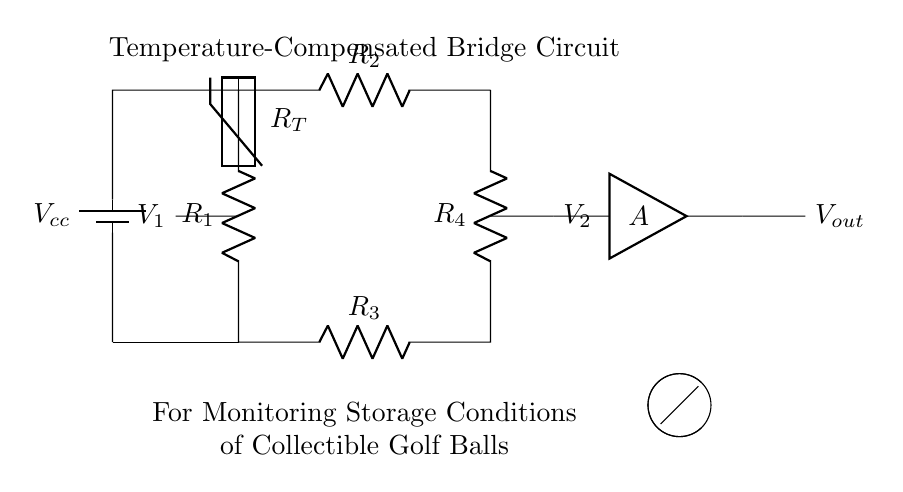What type of circuit is displayed? The circuit is a bridge circuit, which is designed to measure differences in voltage levels, especially useful in sensors and thermistor applications.
Answer: bridge circuit What component is used for temperature sensing? The thermistor, represented as a resistor labeled R_T, is used to sense temperature by changing its resistance with temperature variations.
Answer: thermistor How many resistors are present in the circuit? There are four resistors labeled R_1, R_2, R_3, and R_4, which make up part of the bridge configuration for balancing the circuit.
Answer: four What is the purpose of the amplifier in this circuit? The amplifier, labeled as A, is used to amplify the voltage difference between the two nodes V_1 and V_2 in order to provide a clearer output signal for monitoring.
Answer: amplify voltage What is the reference voltage source for the circuit? The reference voltage source is a battery labeled V_cc, which supplies the necessary voltage for the operation of the circuit.
Answer: V_cc Explain the working principle of the bridge circuit. The bridge circuit operates on the principle of measuring the voltage imbalance produced when the resistive elements change (e.g., due to temperature variations) which causes a change in output voltage across the amplifier. The bridge is balanced when the resistances are equal, creating no output voltage. When the thermistor changes due to temperature, it alters the balance, producing a voltage that the amplifier then processes for monitoring.
Answer: measures voltage imbalance 